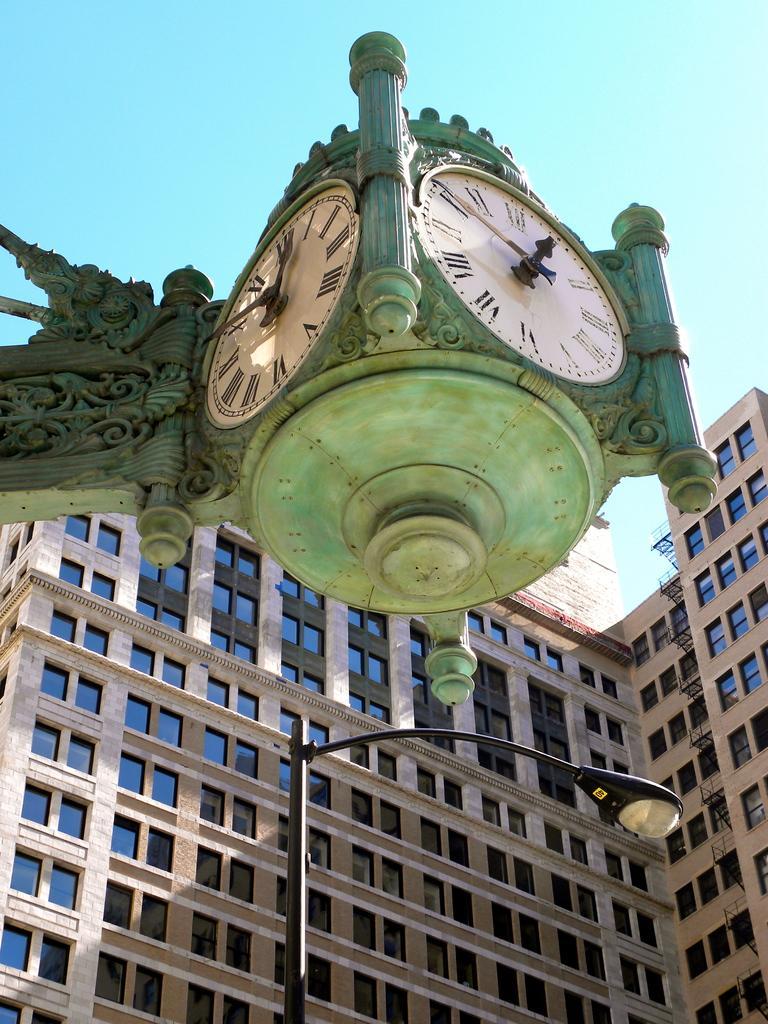Could you give a brief overview of what you see in this image? In the foreground I can see a building, windows, street light and two clocks mounted on a wall. In the background I can see the blue sky. This image is taken may be during a day. 